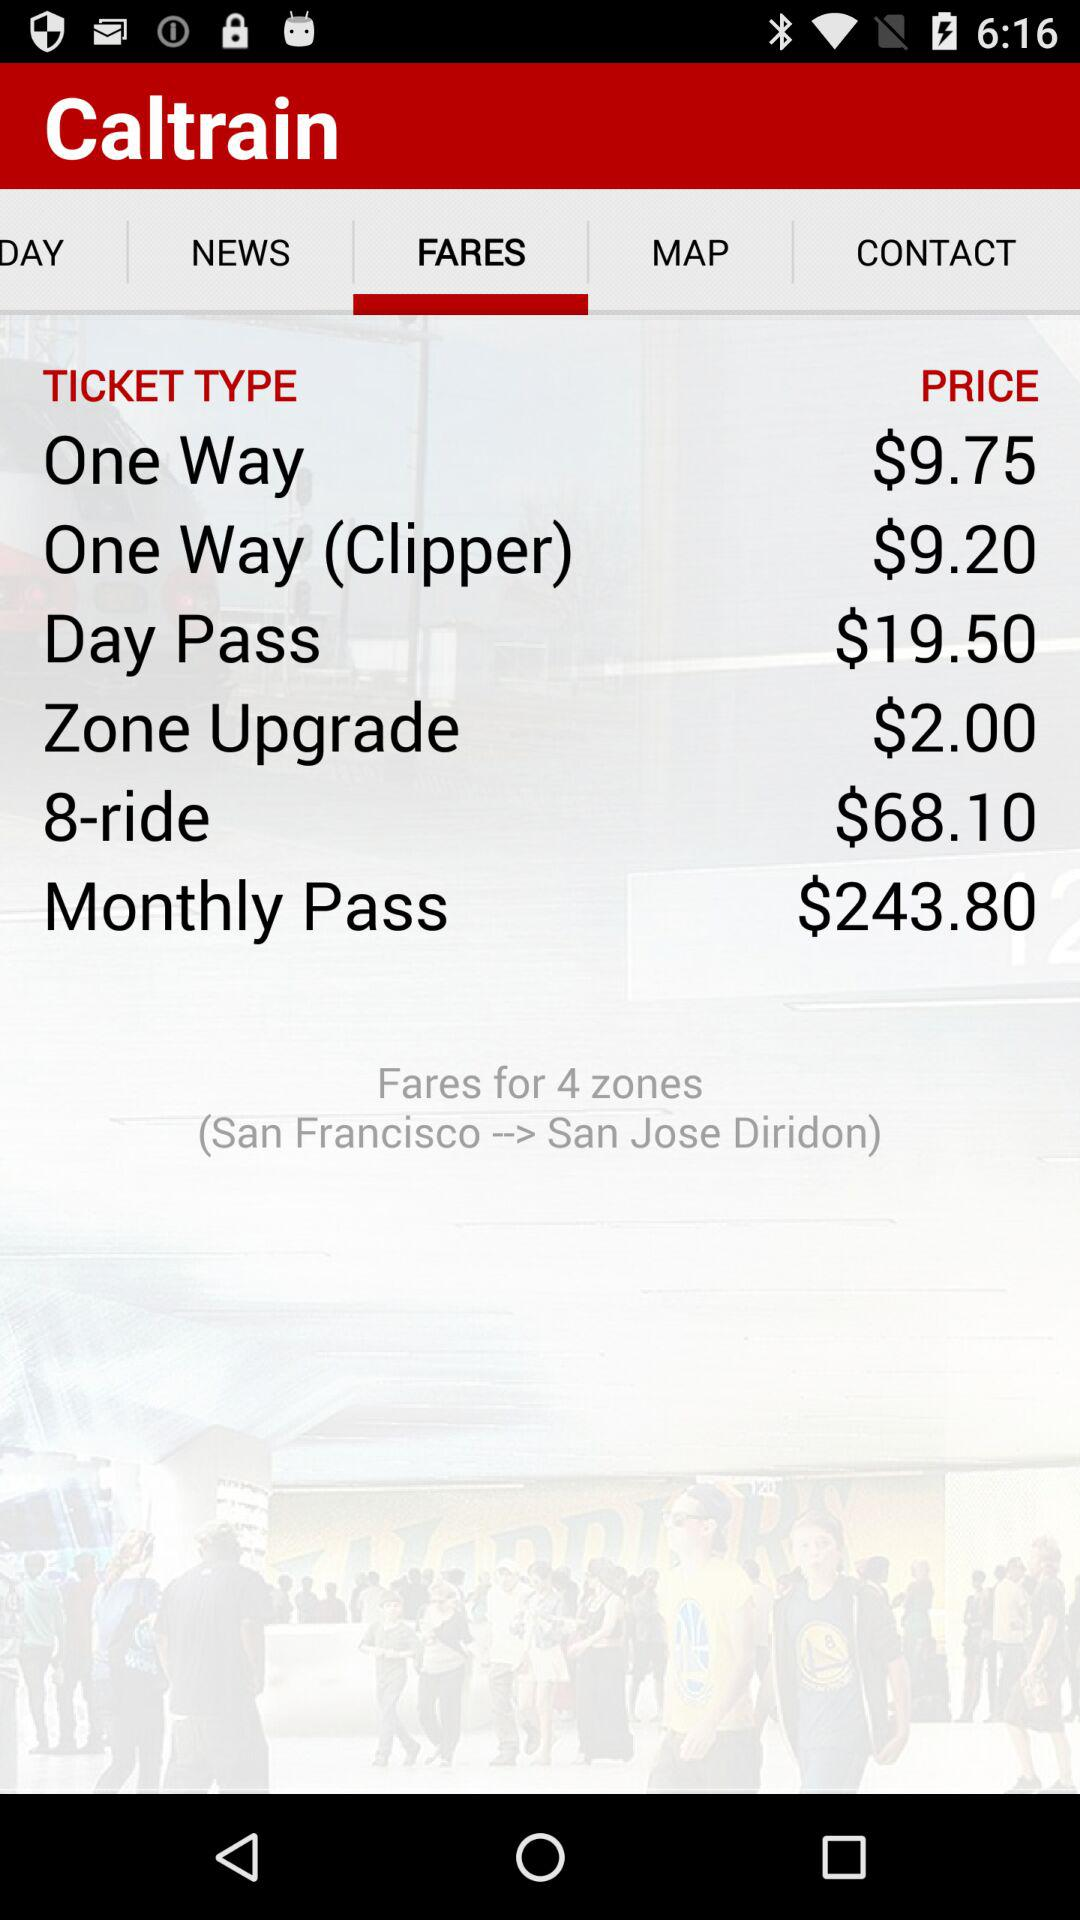Which tab is currently selected? The currently selected tab is "FARES". 